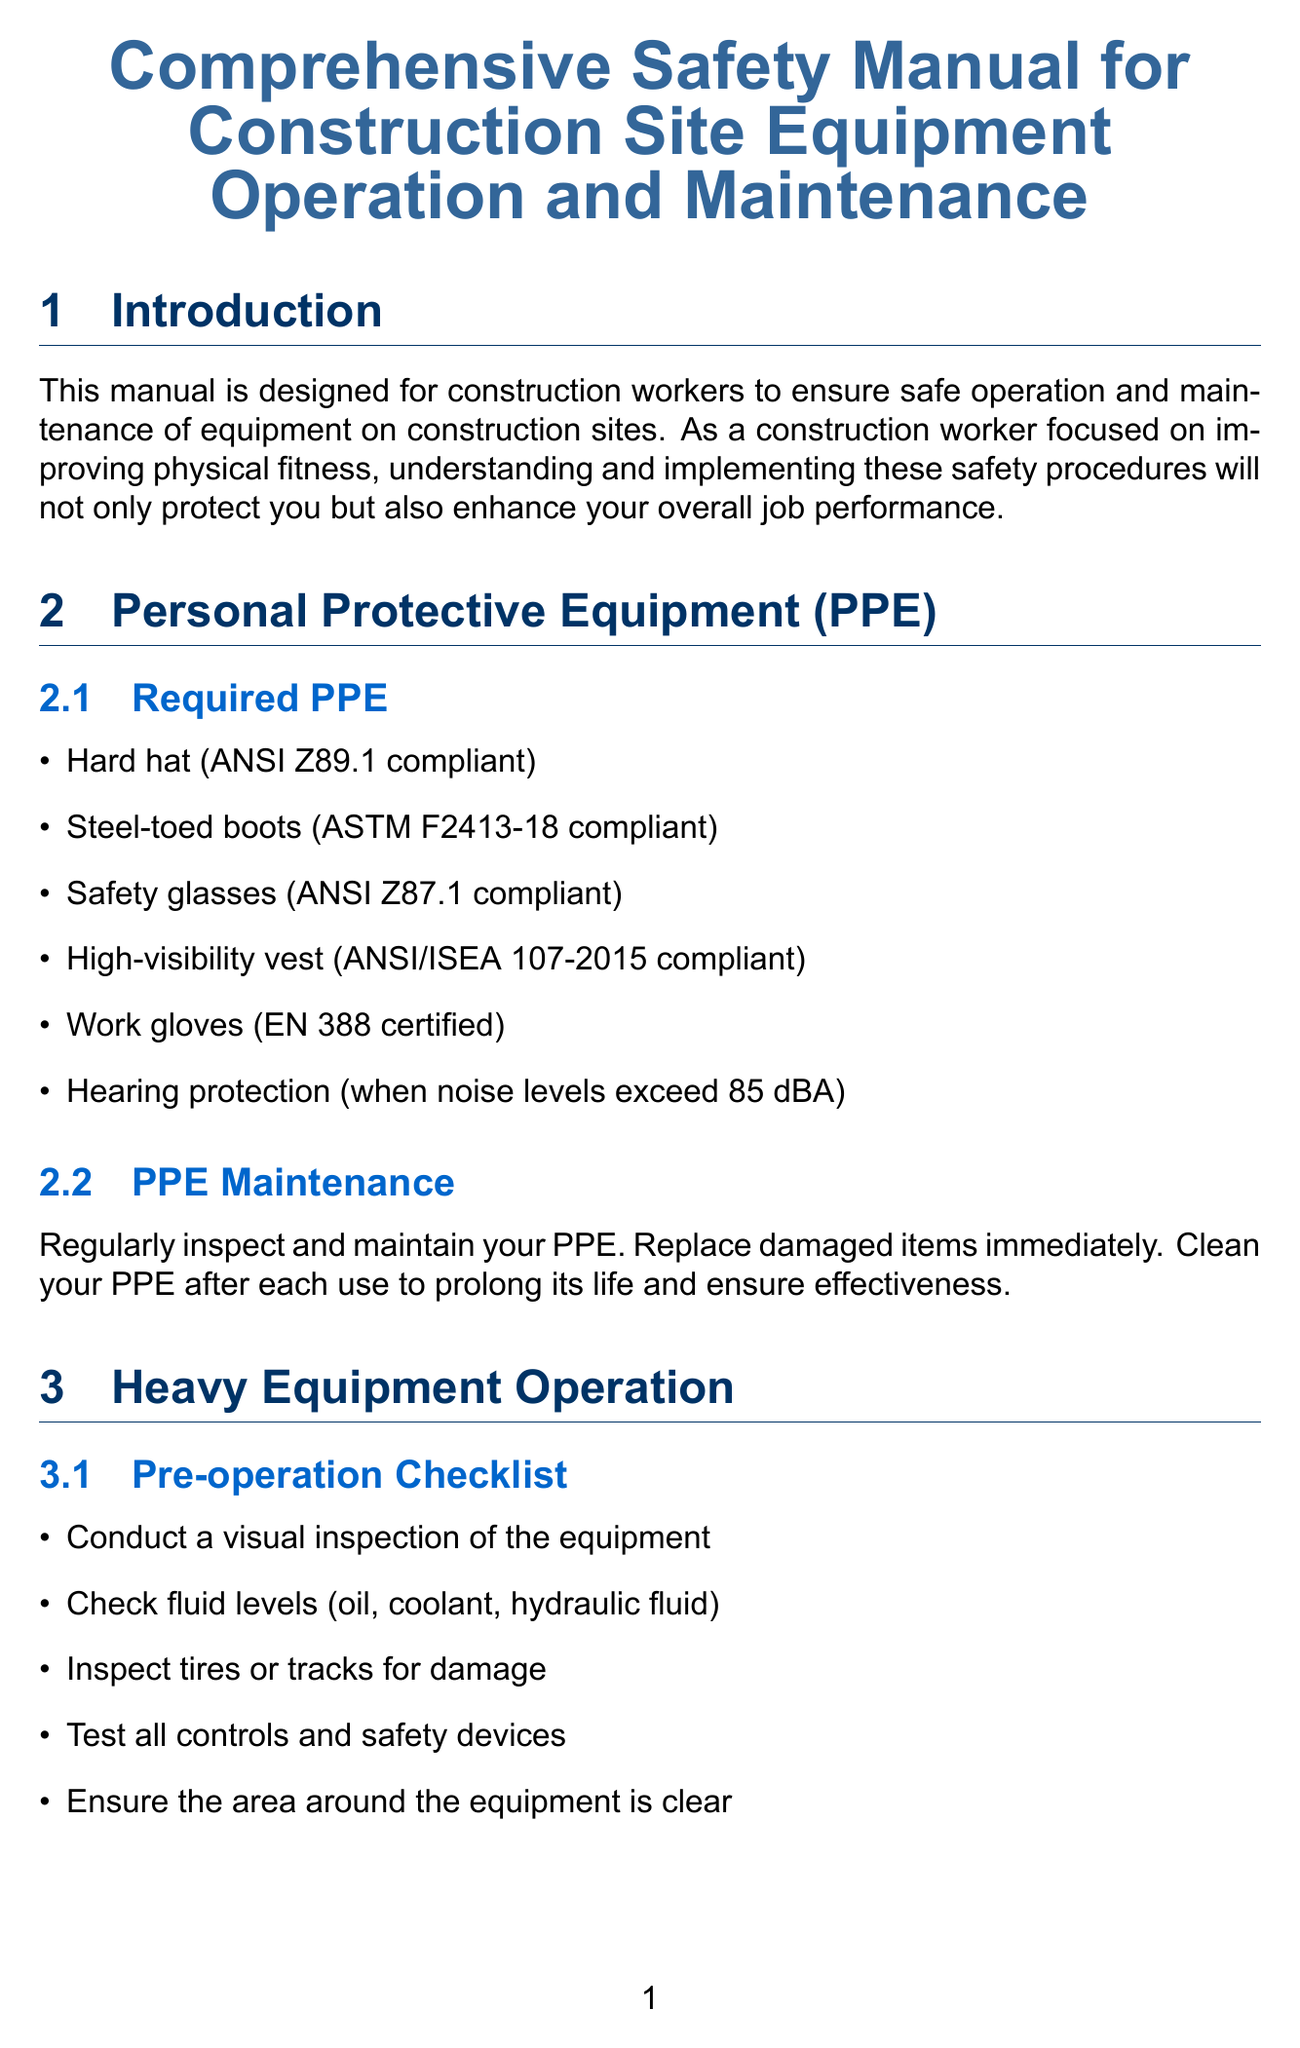What is the title of the manual? The title of the manual is specified at the beginning of the document.
Answer: Comprehensive Safety Manual for Construction Site Equipment Operation and Maintenance What is required PPE? The section lists the necessary personal protective equipment for safe operation.
Answer: Hard hat (ANSI Z89.1 compliant), Steel-toed boots (ASTM F2413-18 compliant), Safety glasses (ANSI Z87.1 compliant), High-visibility vest (ANSI/ISEA 107-2015 compliant), Work gloves (EN 388 certified), Hearing protection (when noise levels exceed 85 dBA) What should you inspect before operating heavy equipment? The document specifies a pre-operation checklist that includes several items to check.
Answer: Conduct a visual inspection of the equipment What is one safe operation practice? This section describes operational safety measures that should be followed.
Answer: Always maintain three points of contact when entering or exiting equipment What maintenance should be performed daily? The daily maintenance section outlines tasks that need to be completed post-operation.
Answer: Clean equipment after use What should be done during an equipment failure? This part details the immediate actions to take if equipment fails during operation.
Answer: Immediately stop operation and lower any raised loads if safe to do so How can physical fitness benefit equipment operation? The document explains the relevance of fitness in improving job performance.
Answer: Improve your stamina, flexibility, and reaction time What is included under scheduled maintenance? This section specifies procedures that should be followed for equipment upkeep.
Answer: Follow the manufacturer's recommended maintenance schedule What does it mean to maintain PPE? The document highlights the importance of proper care for personal protective gear.
Answer: Regularly inspect and maintain your PPE What certification might be needed for crane operators? The section on training and certification lists various certifications necessary for safe operation.
Answer: NCCCO (National Commission for the Certification of Crane Operators) 